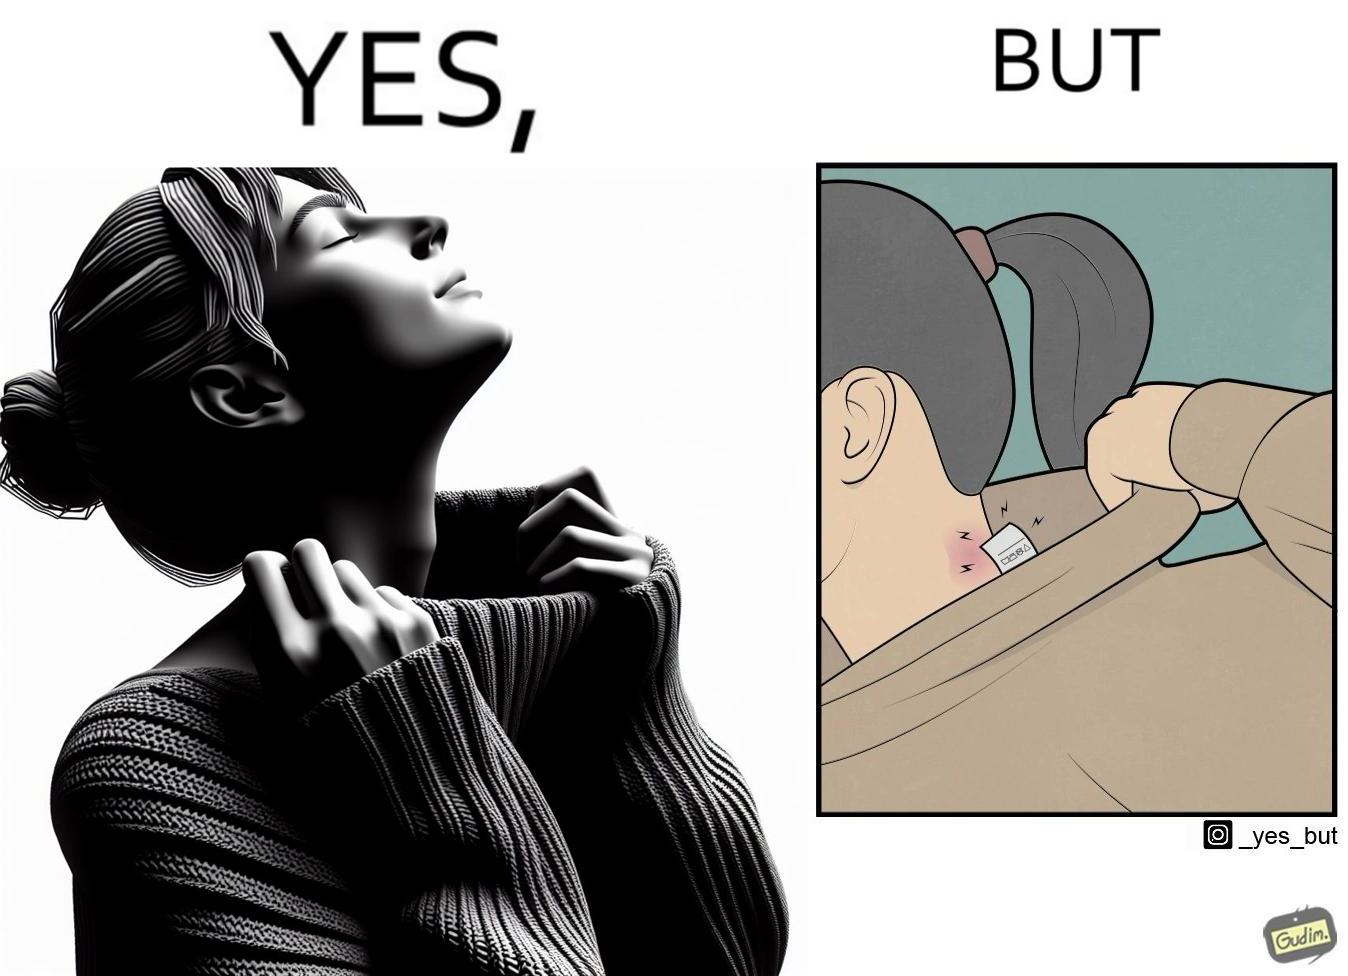What does this image depict? The images are funny since it shows how even though sweaters and other clothings provide much comfort, a tiny manufacturers tag ends up causing the user a lot of discomfort due to constant scratching 